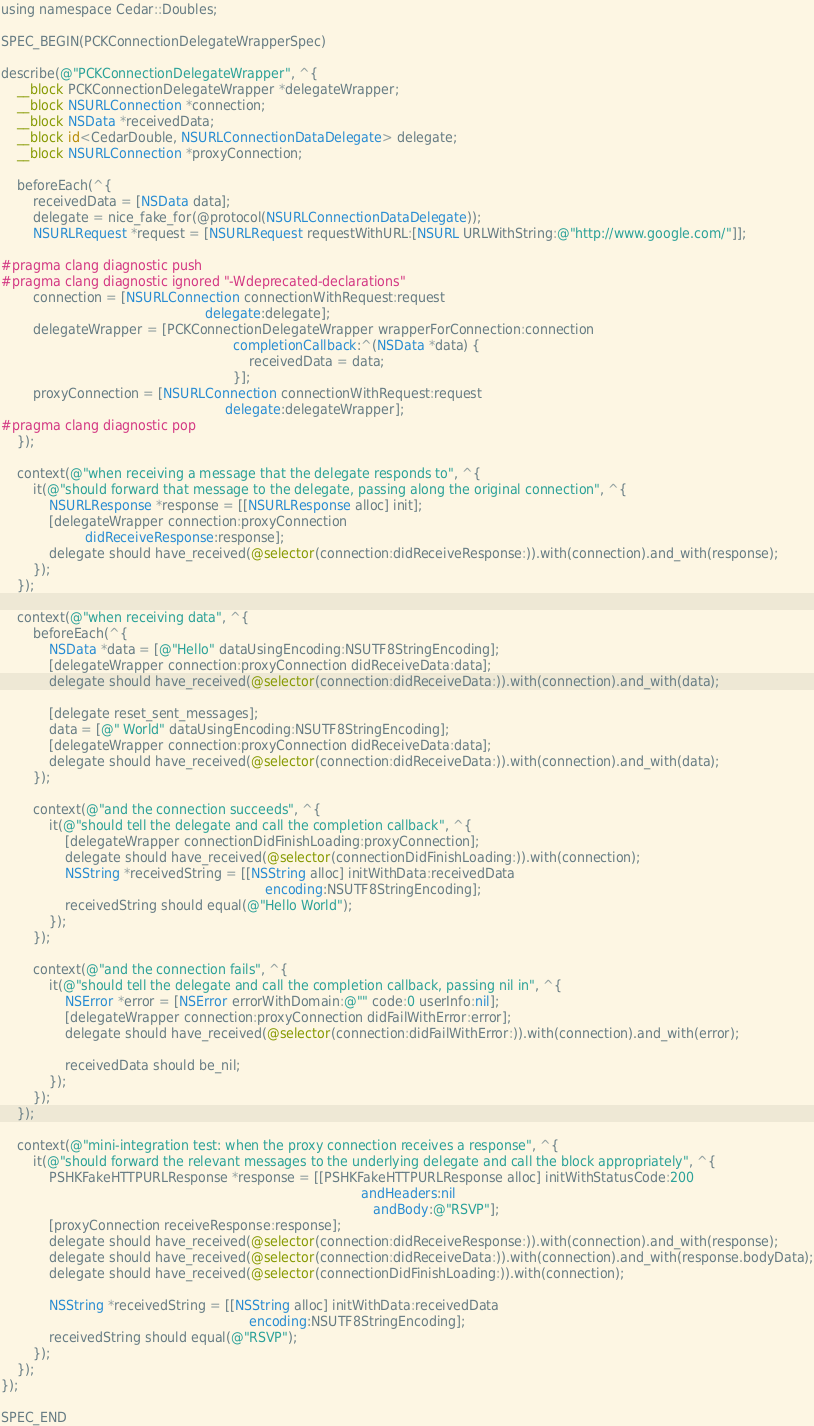<code> <loc_0><loc_0><loc_500><loc_500><_ObjectiveC_>using namespace Cedar::Doubles;

SPEC_BEGIN(PCKConnectionDelegateWrapperSpec)

describe(@"PCKConnectionDelegateWrapper", ^{
    __block PCKConnectionDelegateWrapper *delegateWrapper;
    __block NSURLConnection *connection;
    __block NSData *receivedData;
    __block id<CedarDouble, NSURLConnectionDataDelegate> delegate;
    __block NSURLConnection *proxyConnection;

    beforeEach(^{
        receivedData = [NSData data];
        delegate = nice_fake_for(@protocol(NSURLConnectionDataDelegate));
        NSURLRequest *request = [NSURLRequest requestWithURL:[NSURL URLWithString:@"http://www.google.com/"]];

#pragma clang diagnostic push
#pragma clang diagnostic ignored "-Wdeprecated-declarations"
        connection = [NSURLConnection connectionWithRequest:request
                                                   delegate:delegate];
        delegateWrapper = [PCKConnectionDelegateWrapper wrapperForConnection:connection
                                                          completionCallback:^(NSData *data) {
                                                              receivedData = data;
                                                          }];
        proxyConnection = [NSURLConnection connectionWithRequest:request
                                                        delegate:delegateWrapper];
#pragma clang diagnostic pop
    });

    context(@"when receiving a message that the delegate responds to", ^{
        it(@"should forward that message to the delegate, passing along the original connection", ^{
            NSURLResponse *response = [[NSURLResponse alloc] init];
            [delegateWrapper connection:proxyConnection
                     didReceiveResponse:response];
            delegate should have_received(@selector(connection:didReceiveResponse:)).with(connection).and_with(response);
        });
    });

    context(@"when receiving data", ^{
        beforeEach(^{
            NSData *data = [@"Hello" dataUsingEncoding:NSUTF8StringEncoding];
            [delegateWrapper connection:proxyConnection didReceiveData:data];
            delegate should have_received(@selector(connection:didReceiveData:)).with(connection).and_with(data);

            [delegate reset_sent_messages];
            data = [@" World" dataUsingEncoding:NSUTF8StringEncoding];
            [delegateWrapper connection:proxyConnection didReceiveData:data];
            delegate should have_received(@selector(connection:didReceiveData:)).with(connection).and_with(data);
        });

        context(@"and the connection succeeds", ^{
            it(@"should tell the delegate and call the completion callback", ^{
                [delegateWrapper connectionDidFinishLoading:proxyConnection];
                delegate should have_received(@selector(connectionDidFinishLoading:)).with(connection);
                NSString *receivedString = [[NSString alloc] initWithData:receivedData
                                                                  encoding:NSUTF8StringEncoding];
                receivedString should equal(@"Hello World");
            });
        });

        context(@"and the connection fails", ^{
            it(@"should tell the delegate and call the completion callback, passing nil in", ^{
                NSError *error = [NSError errorWithDomain:@"" code:0 userInfo:nil];
                [delegateWrapper connection:proxyConnection didFailWithError:error];
                delegate should have_received(@selector(connection:didFailWithError:)).with(connection).and_with(error);

                receivedData should be_nil;
            });
        });
    });

    context(@"mini-integration test: when the proxy connection receives a response", ^{
        it(@"should forward the relevant messages to the underlying delegate and call the block appropriately", ^{
            PSHKFakeHTTPURLResponse *response = [[PSHKFakeHTTPURLResponse alloc] initWithStatusCode:200
                                                                                          andHeaders:nil
                                                                                             andBody:@"RSVP"];
            [proxyConnection receiveResponse:response];
            delegate should have_received(@selector(connection:didReceiveResponse:)).with(connection).and_with(response);
            delegate should have_received(@selector(connection:didReceiveData:)).with(connection).and_with(response.bodyData);
            delegate should have_received(@selector(connectionDidFinishLoading:)).with(connection);

            NSString *receivedString = [[NSString alloc] initWithData:receivedData
                                                              encoding:NSUTF8StringEncoding];
            receivedString should equal(@"RSVP");
        });
    });
});

SPEC_END
</code> 